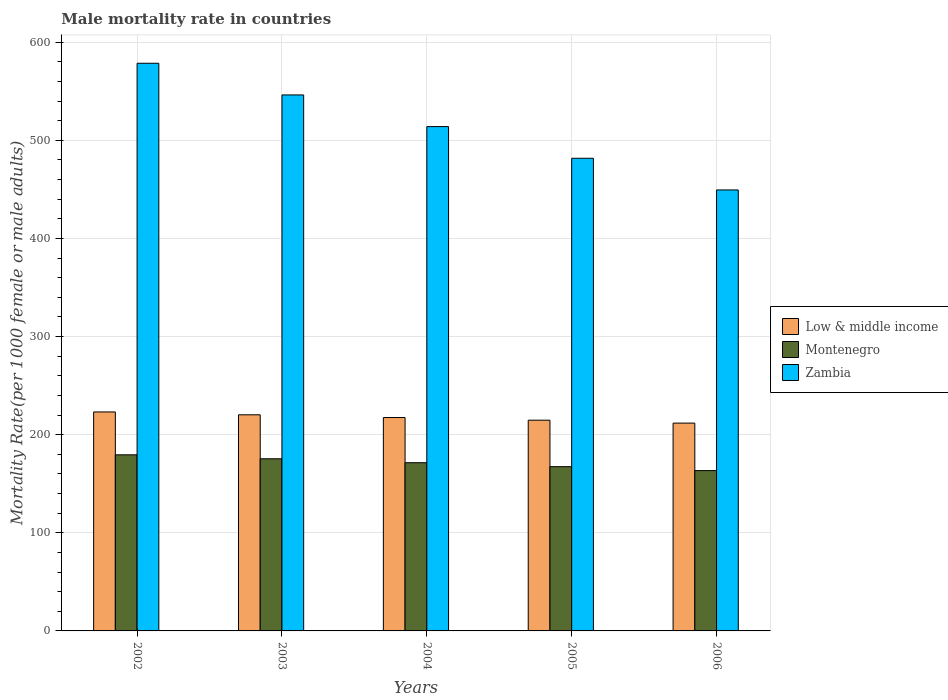How many bars are there on the 5th tick from the right?
Your response must be concise. 3. In how many cases, is the number of bars for a given year not equal to the number of legend labels?
Your response must be concise. 0. What is the male mortality rate in Zambia in 2005?
Provide a succinct answer. 481.68. Across all years, what is the maximum male mortality rate in Zambia?
Your answer should be very brief. 578.52. Across all years, what is the minimum male mortality rate in Zambia?
Offer a very short reply. 449.41. What is the total male mortality rate in Low & middle income in the graph?
Offer a very short reply. 1087.45. What is the difference between the male mortality rate in Montenegro in 2003 and that in 2005?
Your answer should be compact. 8.04. What is the difference between the male mortality rate in Low & middle income in 2002 and the male mortality rate in Zambia in 2004?
Offer a terse response. -290.8. What is the average male mortality rate in Montenegro per year?
Offer a very short reply. 171.42. In the year 2002, what is the difference between the male mortality rate in Zambia and male mortality rate in Montenegro?
Ensure brevity in your answer.  399.05. What is the ratio of the male mortality rate in Montenegro in 2002 to that in 2004?
Your answer should be very brief. 1.05. Is the difference between the male mortality rate in Zambia in 2002 and 2003 greater than the difference between the male mortality rate in Montenegro in 2002 and 2003?
Offer a very short reply. Yes. What is the difference between the highest and the second highest male mortality rate in Low & middle income?
Keep it short and to the point. 2.92. What is the difference between the highest and the lowest male mortality rate in Montenegro?
Offer a terse response. 16.09. In how many years, is the male mortality rate in Zambia greater than the average male mortality rate in Zambia taken over all years?
Your answer should be compact. 2. Is the sum of the male mortality rate in Montenegro in 2002 and 2004 greater than the maximum male mortality rate in Low & middle income across all years?
Your answer should be compact. Yes. What does the 2nd bar from the right in 2004 represents?
Your answer should be compact. Montenegro. How many bars are there?
Keep it short and to the point. 15. Are all the bars in the graph horizontal?
Your response must be concise. No. How many years are there in the graph?
Provide a succinct answer. 5. Are the values on the major ticks of Y-axis written in scientific E-notation?
Your response must be concise. No. How are the legend labels stacked?
Ensure brevity in your answer.  Vertical. What is the title of the graph?
Keep it short and to the point. Male mortality rate in countries. What is the label or title of the Y-axis?
Provide a short and direct response. Mortality Rate(per 1000 female or male adults). What is the Mortality Rate(per 1000 female or male adults) in Low & middle income in 2002?
Ensure brevity in your answer.  223.17. What is the Mortality Rate(per 1000 female or male adults) of Montenegro in 2002?
Your answer should be compact. 179.46. What is the Mortality Rate(per 1000 female or male adults) of Zambia in 2002?
Your answer should be compact. 578.52. What is the Mortality Rate(per 1000 female or male adults) in Low & middle income in 2003?
Provide a succinct answer. 220.25. What is the Mortality Rate(per 1000 female or male adults) of Montenegro in 2003?
Your response must be concise. 175.44. What is the Mortality Rate(per 1000 female or male adults) of Zambia in 2003?
Your answer should be very brief. 546.24. What is the Mortality Rate(per 1000 female or male adults) of Low & middle income in 2004?
Provide a succinct answer. 217.47. What is the Mortality Rate(per 1000 female or male adults) of Montenegro in 2004?
Ensure brevity in your answer.  171.42. What is the Mortality Rate(per 1000 female or male adults) in Zambia in 2004?
Ensure brevity in your answer.  513.96. What is the Mortality Rate(per 1000 female or male adults) in Low & middle income in 2005?
Make the answer very short. 214.76. What is the Mortality Rate(per 1000 female or male adults) in Montenegro in 2005?
Ensure brevity in your answer.  167.4. What is the Mortality Rate(per 1000 female or male adults) in Zambia in 2005?
Ensure brevity in your answer.  481.68. What is the Mortality Rate(per 1000 female or male adults) of Low & middle income in 2006?
Provide a succinct answer. 211.8. What is the Mortality Rate(per 1000 female or male adults) of Montenegro in 2006?
Ensure brevity in your answer.  163.38. What is the Mortality Rate(per 1000 female or male adults) of Zambia in 2006?
Your answer should be very brief. 449.41. Across all years, what is the maximum Mortality Rate(per 1000 female or male adults) of Low & middle income?
Keep it short and to the point. 223.17. Across all years, what is the maximum Mortality Rate(per 1000 female or male adults) of Montenegro?
Your response must be concise. 179.46. Across all years, what is the maximum Mortality Rate(per 1000 female or male adults) in Zambia?
Offer a very short reply. 578.52. Across all years, what is the minimum Mortality Rate(per 1000 female or male adults) of Low & middle income?
Your answer should be very brief. 211.8. Across all years, what is the minimum Mortality Rate(per 1000 female or male adults) of Montenegro?
Provide a succinct answer. 163.38. Across all years, what is the minimum Mortality Rate(per 1000 female or male adults) in Zambia?
Give a very brief answer. 449.41. What is the total Mortality Rate(per 1000 female or male adults) of Low & middle income in the graph?
Provide a short and direct response. 1087.45. What is the total Mortality Rate(per 1000 female or male adults) of Montenegro in the graph?
Offer a terse response. 857.1. What is the total Mortality Rate(per 1000 female or male adults) of Zambia in the graph?
Provide a succinct answer. 2569.81. What is the difference between the Mortality Rate(per 1000 female or male adults) of Low & middle income in 2002 and that in 2003?
Provide a succinct answer. 2.92. What is the difference between the Mortality Rate(per 1000 female or male adults) of Montenegro in 2002 and that in 2003?
Make the answer very short. 4.02. What is the difference between the Mortality Rate(per 1000 female or male adults) in Zambia in 2002 and that in 2003?
Your answer should be very brief. 32.28. What is the difference between the Mortality Rate(per 1000 female or male adults) in Low & middle income in 2002 and that in 2004?
Your answer should be very brief. 5.69. What is the difference between the Mortality Rate(per 1000 female or male adults) of Montenegro in 2002 and that in 2004?
Provide a succinct answer. 8.04. What is the difference between the Mortality Rate(per 1000 female or male adults) of Zambia in 2002 and that in 2004?
Give a very brief answer. 64.56. What is the difference between the Mortality Rate(per 1000 female or male adults) in Low & middle income in 2002 and that in 2005?
Keep it short and to the point. 8.41. What is the difference between the Mortality Rate(per 1000 female or male adults) in Montenegro in 2002 and that in 2005?
Offer a very short reply. 12.06. What is the difference between the Mortality Rate(per 1000 female or male adults) in Zambia in 2002 and that in 2005?
Ensure brevity in your answer.  96.83. What is the difference between the Mortality Rate(per 1000 female or male adults) of Low & middle income in 2002 and that in 2006?
Your answer should be compact. 11.36. What is the difference between the Mortality Rate(per 1000 female or male adults) in Montenegro in 2002 and that in 2006?
Provide a succinct answer. 16.09. What is the difference between the Mortality Rate(per 1000 female or male adults) of Zambia in 2002 and that in 2006?
Keep it short and to the point. 129.11. What is the difference between the Mortality Rate(per 1000 female or male adults) of Low & middle income in 2003 and that in 2004?
Your answer should be compact. 2.78. What is the difference between the Mortality Rate(per 1000 female or male adults) in Montenegro in 2003 and that in 2004?
Offer a terse response. 4.02. What is the difference between the Mortality Rate(per 1000 female or male adults) in Zambia in 2003 and that in 2004?
Your response must be concise. 32.28. What is the difference between the Mortality Rate(per 1000 female or male adults) in Low & middle income in 2003 and that in 2005?
Make the answer very short. 5.49. What is the difference between the Mortality Rate(per 1000 female or male adults) in Montenegro in 2003 and that in 2005?
Provide a short and direct response. 8.04. What is the difference between the Mortality Rate(per 1000 female or male adults) of Zambia in 2003 and that in 2005?
Your answer should be very brief. 64.56. What is the difference between the Mortality Rate(per 1000 female or male adults) in Low & middle income in 2003 and that in 2006?
Offer a very short reply. 8.45. What is the difference between the Mortality Rate(per 1000 female or male adults) of Montenegro in 2003 and that in 2006?
Your answer should be compact. 12.06. What is the difference between the Mortality Rate(per 1000 female or male adults) in Zambia in 2003 and that in 2006?
Your response must be concise. 96.83. What is the difference between the Mortality Rate(per 1000 female or male adults) in Low & middle income in 2004 and that in 2005?
Offer a very short reply. 2.71. What is the difference between the Mortality Rate(per 1000 female or male adults) of Montenegro in 2004 and that in 2005?
Your answer should be very brief. 4.02. What is the difference between the Mortality Rate(per 1000 female or male adults) of Zambia in 2004 and that in 2005?
Your answer should be very brief. 32.28. What is the difference between the Mortality Rate(per 1000 female or male adults) of Low & middle income in 2004 and that in 2006?
Your response must be concise. 5.67. What is the difference between the Mortality Rate(per 1000 female or male adults) in Montenegro in 2004 and that in 2006?
Ensure brevity in your answer.  8.04. What is the difference between the Mortality Rate(per 1000 female or male adults) of Zambia in 2004 and that in 2006?
Ensure brevity in your answer.  64.56. What is the difference between the Mortality Rate(per 1000 female or male adults) of Low & middle income in 2005 and that in 2006?
Offer a terse response. 2.96. What is the difference between the Mortality Rate(per 1000 female or male adults) of Montenegro in 2005 and that in 2006?
Offer a very short reply. 4.02. What is the difference between the Mortality Rate(per 1000 female or male adults) in Zambia in 2005 and that in 2006?
Give a very brief answer. 32.28. What is the difference between the Mortality Rate(per 1000 female or male adults) in Low & middle income in 2002 and the Mortality Rate(per 1000 female or male adults) in Montenegro in 2003?
Offer a terse response. 47.72. What is the difference between the Mortality Rate(per 1000 female or male adults) of Low & middle income in 2002 and the Mortality Rate(per 1000 female or male adults) of Zambia in 2003?
Provide a short and direct response. -323.07. What is the difference between the Mortality Rate(per 1000 female or male adults) in Montenegro in 2002 and the Mortality Rate(per 1000 female or male adults) in Zambia in 2003?
Keep it short and to the point. -366.78. What is the difference between the Mortality Rate(per 1000 female or male adults) in Low & middle income in 2002 and the Mortality Rate(per 1000 female or male adults) in Montenegro in 2004?
Your answer should be compact. 51.74. What is the difference between the Mortality Rate(per 1000 female or male adults) of Low & middle income in 2002 and the Mortality Rate(per 1000 female or male adults) of Zambia in 2004?
Offer a very short reply. -290.8. What is the difference between the Mortality Rate(per 1000 female or male adults) in Montenegro in 2002 and the Mortality Rate(per 1000 female or male adults) in Zambia in 2004?
Make the answer very short. -334.5. What is the difference between the Mortality Rate(per 1000 female or male adults) in Low & middle income in 2002 and the Mortality Rate(per 1000 female or male adults) in Montenegro in 2005?
Your answer should be very brief. 55.77. What is the difference between the Mortality Rate(per 1000 female or male adults) of Low & middle income in 2002 and the Mortality Rate(per 1000 female or male adults) of Zambia in 2005?
Offer a terse response. -258.52. What is the difference between the Mortality Rate(per 1000 female or male adults) in Montenegro in 2002 and the Mortality Rate(per 1000 female or male adults) in Zambia in 2005?
Your answer should be very brief. -302.22. What is the difference between the Mortality Rate(per 1000 female or male adults) in Low & middle income in 2002 and the Mortality Rate(per 1000 female or male adults) in Montenegro in 2006?
Make the answer very short. 59.79. What is the difference between the Mortality Rate(per 1000 female or male adults) of Low & middle income in 2002 and the Mortality Rate(per 1000 female or male adults) of Zambia in 2006?
Keep it short and to the point. -226.24. What is the difference between the Mortality Rate(per 1000 female or male adults) in Montenegro in 2002 and the Mortality Rate(per 1000 female or male adults) in Zambia in 2006?
Make the answer very short. -269.94. What is the difference between the Mortality Rate(per 1000 female or male adults) of Low & middle income in 2003 and the Mortality Rate(per 1000 female or male adults) of Montenegro in 2004?
Ensure brevity in your answer.  48.83. What is the difference between the Mortality Rate(per 1000 female or male adults) in Low & middle income in 2003 and the Mortality Rate(per 1000 female or male adults) in Zambia in 2004?
Make the answer very short. -293.71. What is the difference between the Mortality Rate(per 1000 female or male adults) in Montenegro in 2003 and the Mortality Rate(per 1000 female or male adults) in Zambia in 2004?
Your response must be concise. -338.52. What is the difference between the Mortality Rate(per 1000 female or male adults) in Low & middle income in 2003 and the Mortality Rate(per 1000 female or male adults) in Montenegro in 2005?
Ensure brevity in your answer.  52.85. What is the difference between the Mortality Rate(per 1000 female or male adults) of Low & middle income in 2003 and the Mortality Rate(per 1000 female or male adults) of Zambia in 2005?
Give a very brief answer. -261.44. What is the difference between the Mortality Rate(per 1000 female or male adults) of Montenegro in 2003 and the Mortality Rate(per 1000 female or male adults) of Zambia in 2005?
Your response must be concise. -306.24. What is the difference between the Mortality Rate(per 1000 female or male adults) in Low & middle income in 2003 and the Mortality Rate(per 1000 female or male adults) in Montenegro in 2006?
Make the answer very short. 56.87. What is the difference between the Mortality Rate(per 1000 female or male adults) in Low & middle income in 2003 and the Mortality Rate(per 1000 female or male adults) in Zambia in 2006?
Make the answer very short. -229.16. What is the difference between the Mortality Rate(per 1000 female or male adults) of Montenegro in 2003 and the Mortality Rate(per 1000 female or male adults) of Zambia in 2006?
Give a very brief answer. -273.96. What is the difference between the Mortality Rate(per 1000 female or male adults) of Low & middle income in 2004 and the Mortality Rate(per 1000 female or male adults) of Montenegro in 2005?
Your response must be concise. 50.07. What is the difference between the Mortality Rate(per 1000 female or male adults) in Low & middle income in 2004 and the Mortality Rate(per 1000 female or male adults) in Zambia in 2005?
Offer a terse response. -264.21. What is the difference between the Mortality Rate(per 1000 female or male adults) of Montenegro in 2004 and the Mortality Rate(per 1000 female or male adults) of Zambia in 2005?
Offer a very short reply. -310.26. What is the difference between the Mortality Rate(per 1000 female or male adults) in Low & middle income in 2004 and the Mortality Rate(per 1000 female or male adults) in Montenegro in 2006?
Provide a short and direct response. 54.09. What is the difference between the Mortality Rate(per 1000 female or male adults) in Low & middle income in 2004 and the Mortality Rate(per 1000 female or male adults) in Zambia in 2006?
Provide a succinct answer. -231.93. What is the difference between the Mortality Rate(per 1000 female or male adults) in Montenegro in 2004 and the Mortality Rate(per 1000 female or male adults) in Zambia in 2006?
Give a very brief answer. -277.99. What is the difference between the Mortality Rate(per 1000 female or male adults) in Low & middle income in 2005 and the Mortality Rate(per 1000 female or male adults) in Montenegro in 2006?
Your answer should be compact. 51.38. What is the difference between the Mortality Rate(per 1000 female or male adults) in Low & middle income in 2005 and the Mortality Rate(per 1000 female or male adults) in Zambia in 2006?
Provide a short and direct response. -234.65. What is the difference between the Mortality Rate(per 1000 female or male adults) of Montenegro in 2005 and the Mortality Rate(per 1000 female or male adults) of Zambia in 2006?
Keep it short and to the point. -282.01. What is the average Mortality Rate(per 1000 female or male adults) of Low & middle income per year?
Offer a terse response. 217.49. What is the average Mortality Rate(per 1000 female or male adults) of Montenegro per year?
Your response must be concise. 171.42. What is the average Mortality Rate(per 1000 female or male adults) in Zambia per year?
Your response must be concise. 513.96. In the year 2002, what is the difference between the Mortality Rate(per 1000 female or male adults) in Low & middle income and Mortality Rate(per 1000 female or male adults) in Montenegro?
Your answer should be compact. 43.7. In the year 2002, what is the difference between the Mortality Rate(per 1000 female or male adults) in Low & middle income and Mortality Rate(per 1000 female or male adults) in Zambia?
Ensure brevity in your answer.  -355.35. In the year 2002, what is the difference between the Mortality Rate(per 1000 female or male adults) in Montenegro and Mortality Rate(per 1000 female or male adults) in Zambia?
Ensure brevity in your answer.  -399.05. In the year 2003, what is the difference between the Mortality Rate(per 1000 female or male adults) in Low & middle income and Mortality Rate(per 1000 female or male adults) in Montenegro?
Offer a terse response. 44.81. In the year 2003, what is the difference between the Mortality Rate(per 1000 female or male adults) in Low & middle income and Mortality Rate(per 1000 female or male adults) in Zambia?
Give a very brief answer. -325.99. In the year 2003, what is the difference between the Mortality Rate(per 1000 female or male adults) of Montenegro and Mortality Rate(per 1000 female or male adults) of Zambia?
Offer a very short reply. -370.8. In the year 2004, what is the difference between the Mortality Rate(per 1000 female or male adults) in Low & middle income and Mortality Rate(per 1000 female or male adults) in Montenegro?
Provide a succinct answer. 46.05. In the year 2004, what is the difference between the Mortality Rate(per 1000 female or male adults) in Low & middle income and Mortality Rate(per 1000 female or male adults) in Zambia?
Your answer should be very brief. -296.49. In the year 2004, what is the difference between the Mortality Rate(per 1000 female or male adults) in Montenegro and Mortality Rate(per 1000 female or male adults) in Zambia?
Ensure brevity in your answer.  -342.54. In the year 2005, what is the difference between the Mortality Rate(per 1000 female or male adults) of Low & middle income and Mortality Rate(per 1000 female or male adults) of Montenegro?
Your answer should be compact. 47.36. In the year 2005, what is the difference between the Mortality Rate(per 1000 female or male adults) in Low & middle income and Mortality Rate(per 1000 female or male adults) in Zambia?
Provide a short and direct response. -266.92. In the year 2005, what is the difference between the Mortality Rate(per 1000 female or male adults) of Montenegro and Mortality Rate(per 1000 female or male adults) of Zambia?
Make the answer very short. -314.28. In the year 2006, what is the difference between the Mortality Rate(per 1000 female or male adults) of Low & middle income and Mortality Rate(per 1000 female or male adults) of Montenegro?
Keep it short and to the point. 48.42. In the year 2006, what is the difference between the Mortality Rate(per 1000 female or male adults) in Low & middle income and Mortality Rate(per 1000 female or male adults) in Zambia?
Your answer should be compact. -237.6. In the year 2006, what is the difference between the Mortality Rate(per 1000 female or male adults) of Montenegro and Mortality Rate(per 1000 female or male adults) of Zambia?
Provide a short and direct response. -286.03. What is the ratio of the Mortality Rate(per 1000 female or male adults) in Low & middle income in 2002 to that in 2003?
Your answer should be compact. 1.01. What is the ratio of the Mortality Rate(per 1000 female or male adults) of Montenegro in 2002 to that in 2003?
Give a very brief answer. 1.02. What is the ratio of the Mortality Rate(per 1000 female or male adults) in Zambia in 2002 to that in 2003?
Provide a short and direct response. 1.06. What is the ratio of the Mortality Rate(per 1000 female or male adults) of Low & middle income in 2002 to that in 2004?
Provide a short and direct response. 1.03. What is the ratio of the Mortality Rate(per 1000 female or male adults) in Montenegro in 2002 to that in 2004?
Give a very brief answer. 1.05. What is the ratio of the Mortality Rate(per 1000 female or male adults) in Zambia in 2002 to that in 2004?
Keep it short and to the point. 1.13. What is the ratio of the Mortality Rate(per 1000 female or male adults) of Low & middle income in 2002 to that in 2005?
Offer a terse response. 1.04. What is the ratio of the Mortality Rate(per 1000 female or male adults) in Montenegro in 2002 to that in 2005?
Provide a short and direct response. 1.07. What is the ratio of the Mortality Rate(per 1000 female or male adults) in Zambia in 2002 to that in 2005?
Provide a succinct answer. 1.2. What is the ratio of the Mortality Rate(per 1000 female or male adults) of Low & middle income in 2002 to that in 2006?
Your response must be concise. 1.05. What is the ratio of the Mortality Rate(per 1000 female or male adults) of Montenegro in 2002 to that in 2006?
Your answer should be compact. 1.1. What is the ratio of the Mortality Rate(per 1000 female or male adults) of Zambia in 2002 to that in 2006?
Provide a succinct answer. 1.29. What is the ratio of the Mortality Rate(per 1000 female or male adults) of Low & middle income in 2003 to that in 2004?
Your answer should be compact. 1.01. What is the ratio of the Mortality Rate(per 1000 female or male adults) in Montenegro in 2003 to that in 2004?
Provide a succinct answer. 1.02. What is the ratio of the Mortality Rate(per 1000 female or male adults) in Zambia in 2003 to that in 2004?
Your response must be concise. 1.06. What is the ratio of the Mortality Rate(per 1000 female or male adults) of Low & middle income in 2003 to that in 2005?
Provide a succinct answer. 1.03. What is the ratio of the Mortality Rate(per 1000 female or male adults) of Montenegro in 2003 to that in 2005?
Make the answer very short. 1.05. What is the ratio of the Mortality Rate(per 1000 female or male adults) of Zambia in 2003 to that in 2005?
Your response must be concise. 1.13. What is the ratio of the Mortality Rate(per 1000 female or male adults) of Low & middle income in 2003 to that in 2006?
Ensure brevity in your answer.  1.04. What is the ratio of the Mortality Rate(per 1000 female or male adults) of Montenegro in 2003 to that in 2006?
Make the answer very short. 1.07. What is the ratio of the Mortality Rate(per 1000 female or male adults) of Zambia in 2003 to that in 2006?
Provide a short and direct response. 1.22. What is the ratio of the Mortality Rate(per 1000 female or male adults) of Low & middle income in 2004 to that in 2005?
Your response must be concise. 1.01. What is the ratio of the Mortality Rate(per 1000 female or male adults) in Zambia in 2004 to that in 2005?
Offer a very short reply. 1.07. What is the ratio of the Mortality Rate(per 1000 female or male adults) of Low & middle income in 2004 to that in 2006?
Ensure brevity in your answer.  1.03. What is the ratio of the Mortality Rate(per 1000 female or male adults) of Montenegro in 2004 to that in 2006?
Provide a short and direct response. 1.05. What is the ratio of the Mortality Rate(per 1000 female or male adults) of Zambia in 2004 to that in 2006?
Your answer should be very brief. 1.14. What is the ratio of the Mortality Rate(per 1000 female or male adults) of Low & middle income in 2005 to that in 2006?
Your answer should be very brief. 1.01. What is the ratio of the Mortality Rate(per 1000 female or male adults) of Montenegro in 2005 to that in 2006?
Offer a very short reply. 1.02. What is the ratio of the Mortality Rate(per 1000 female or male adults) of Zambia in 2005 to that in 2006?
Your response must be concise. 1.07. What is the difference between the highest and the second highest Mortality Rate(per 1000 female or male adults) in Low & middle income?
Ensure brevity in your answer.  2.92. What is the difference between the highest and the second highest Mortality Rate(per 1000 female or male adults) in Montenegro?
Your response must be concise. 4.02. What is the difference between the highest and the second highest Mortality Rate(per 1000 female or male adults) of Zambia?
Your answer should be very brief. 32.28. What is the difference between the highest and the lowest Mortality Rate(per 1000 female or male adults) of Low & middle income?
Give a very brief answer. 11.36. What is the difference between the highest and the lowest Mortality Rate(per 1000 female or male adults) of Montenegro?
Keep it short and to the point. 16.09. What is the difference between the highest and the lowest Mortality Rate(per 1000 female or male adults) of Zambia?
Give a very brief answer. 129.11. 